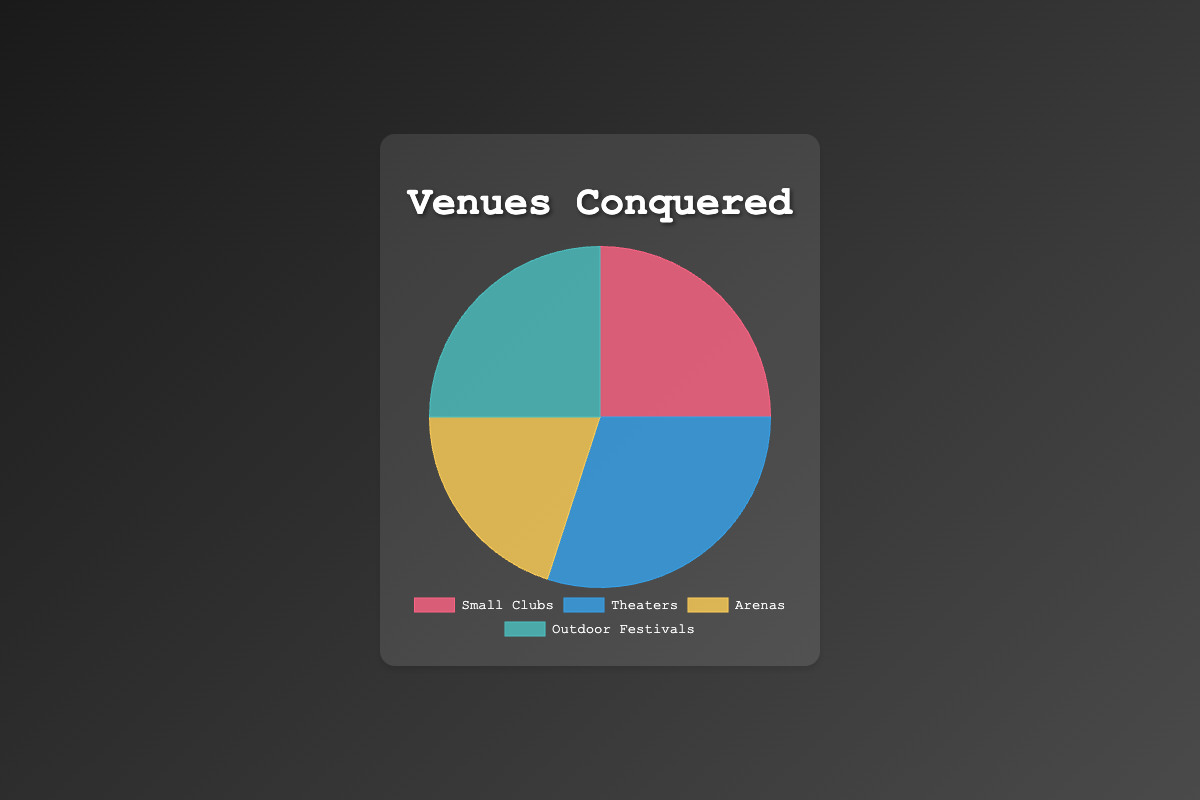Which venue type has the largest proportion of performances? By observing the size of the chart slices, Theaters appear to have the largest slice, indicating they have the highest proportion of performances.
Answer: Theaters What percentage of performances are done in Small Clubs and Outdoor Festivals combined? The percentage of performances in Small Clubs is 25%, and Outdoor Festivals is 25%. Adding these together gives 25% + 25% = 50%.
Answer: 50% How does the number of performances in Arenas compare to those in Theaters? The slice for Arenas represents 20%, which is smaller than the 30% slice for Theaters, indicating fewer performances in Arenas compared to Theaters.
Answer: Theaters have more Are Small Clubs and Outdoor Festivals equally popular venues for performances? The slices for Small Clubs and Outdoor Festivals are of equal size, each representing 25%, indicating equal popularity.
Answer: Yes What is the total percentage of performances in venues other than Theaters? Subtract the percentage of Theaters (30%) from 100% to get the total for other venues: 100% - 30% = 70%.
Answer: 70% Which venue type has the smallest proportion of performances? By observing the chart, Arenas have the smallest slice, representing the smallest proportion of performances at 20%.
Answer: Arenas What is the difference in percentage between the most common and least common venue types? The most common venue type has 30% (Theaters) and the least common has 20% (Arenas). The difference is 30% - 20% = 10%.
Answer: 10% What proportion of performances occur in venues that are not Arenas? The percentage of performances in Arenas is 20%, so subtracting this from 100% gives 100% - 20% = 80%.
Answer: 80% Which venues have the same percentage of performances? Observing the chart shows that Small Clubs and Outdoor Festivals each have 25% of performances.
Answer: Small Clubs and Outdoor Festivals 